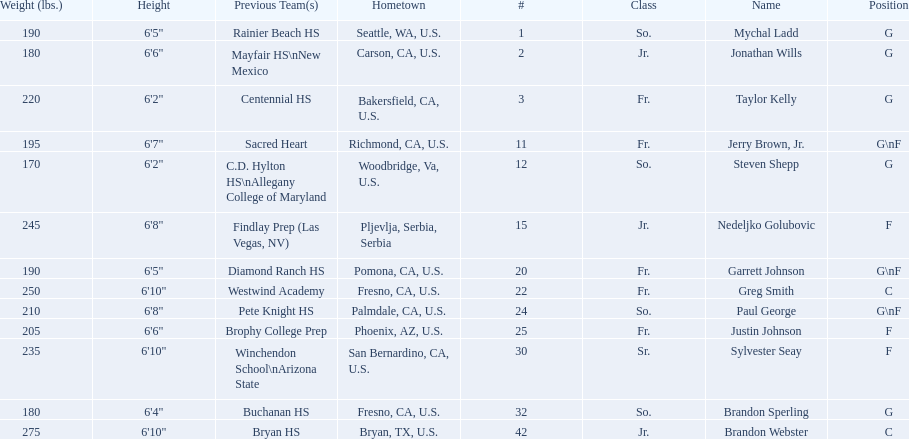Which players are forwards? Nedeljko Golubovic, Paul George, Justin Johnson, Sylvester Seay. What are the heights of these players? Nedeljko Golubovic, 6'8", Paul George, 6'8", Justin Johnson, 6'6", Sylvester Seay, 6'10". Of these players, who is the shortest? Justin Johnson. 